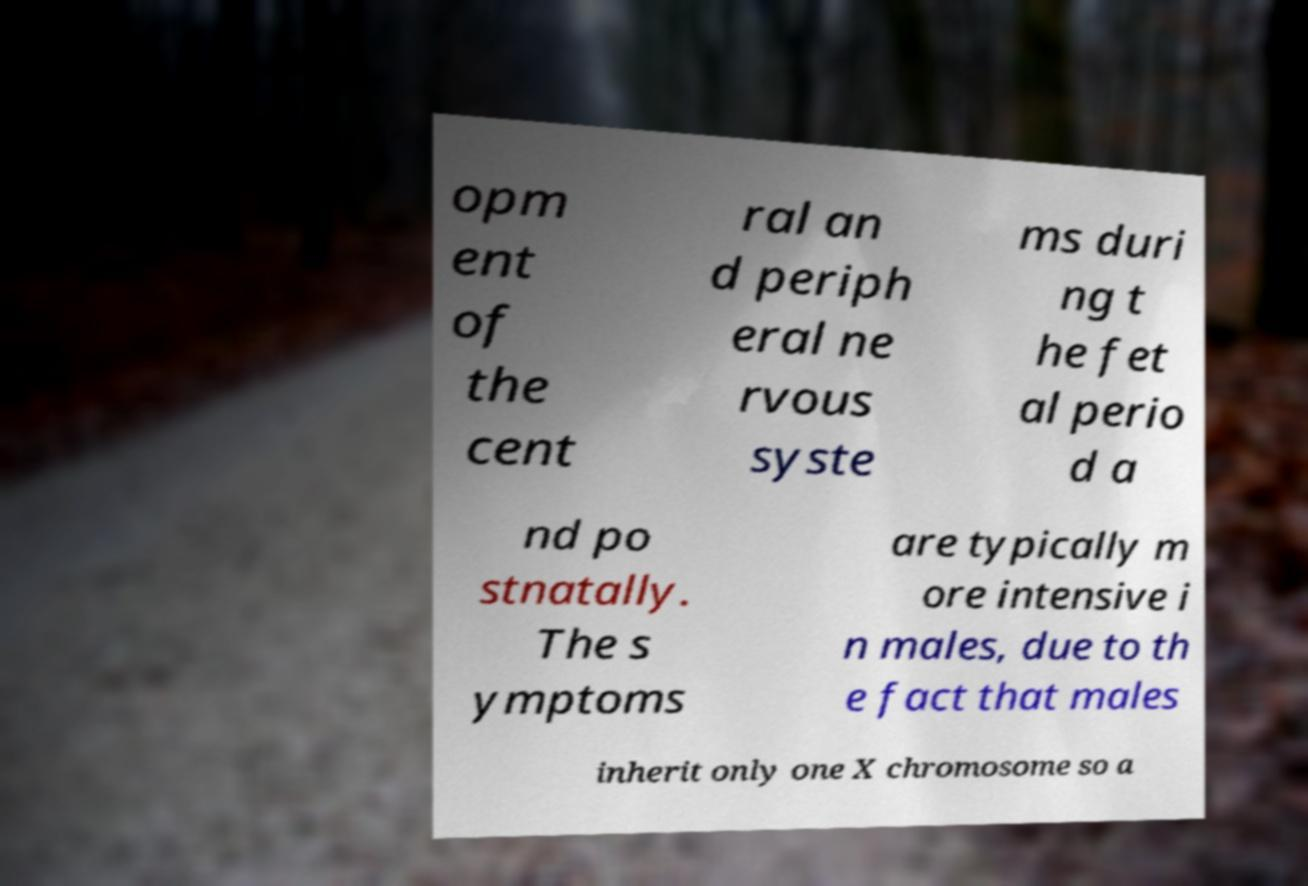I need the written content from this picture converted into text. Can you do that? opm ent of the cent ral an d periph eral ne rvous syste ms duri ng t he fet al perio d a nd po stnatally. The s ymptoms are typically m ore intensive i n males, due to th e fact that males inherit only one X chromosome so a 